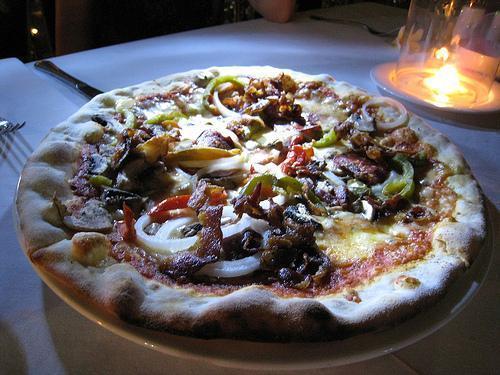How many pizzas are there?
Give a very brief answer. 1. 